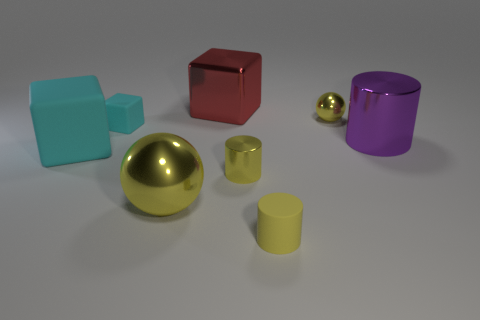Add 1 green blocks. How many objects exist? 9 Subtract all cylinders. How many objects are left? 5 Subtract all large purple metal cubes. Subtract all small yellow objects. How many objects are left? 5 Add 7 rubber cylinders. How many rubber cylinders are left? 8 Add 8 small blue metallic blocks. How many small blue metallic blocks exist? 8 Subtract 1 yellow spheres. How many objects are left? 7 